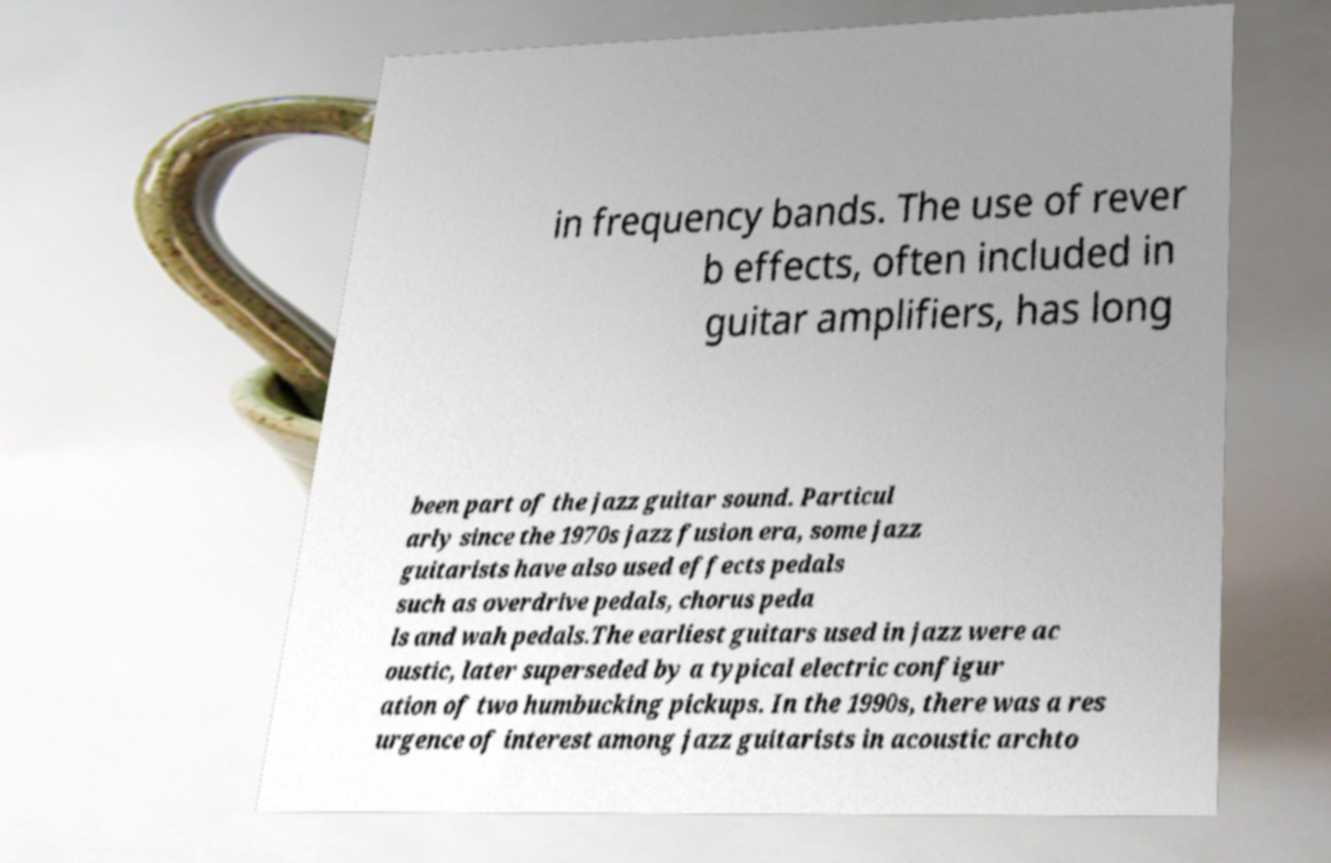Could you extract and type out the text from this image? in frequency bands. The use of rever b effects, often included in guitar amplifiers, has long been part of the jazz guitar sound. Particul arly since the 1970s jazz fusion era, some jazz guitarists have also used effects pedals such as overdrive pedals, chorus peda ls and wah pedals.The earliest guitars used in jazz were ac oustic, later superseded by a typical electric configur ation of two humbucking pickups. In the 1990s, there was a res urgence of interest among jazz guitarists in acoustic archto 